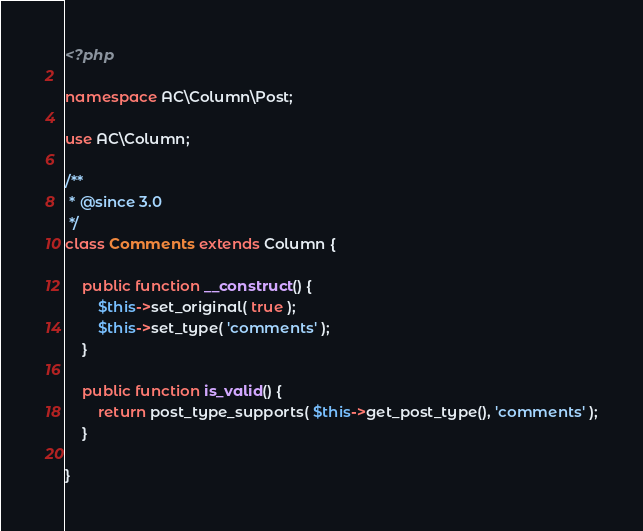<code> <loc_0><loc_0><loc_500><loc_500><_PHP_><?php

namespace AC\Column\Post;

use AC\Column;

/**
 * @since 3.0
 */
class Comments extends Column {

	public function __construct() {
		$this->set_original( true );
		$this->set_type( 'comments' );
	}

	public function is_valid() {
		return post_type_supports( $this->get_post_type(), 'comments' );
	}

}</code> 